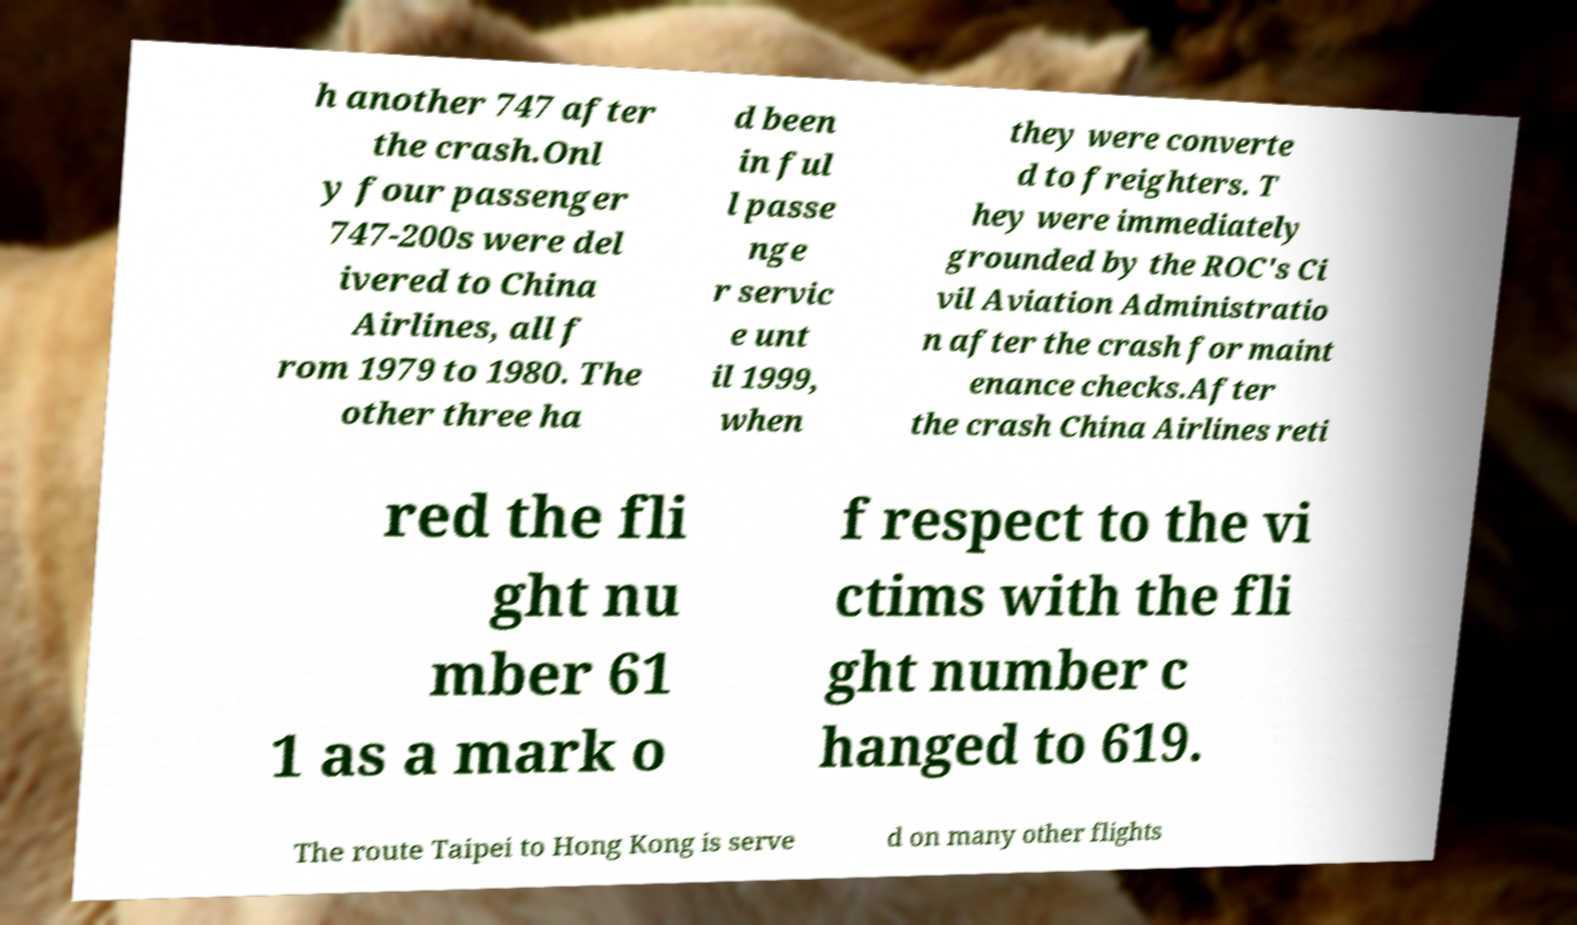There's text embedded in this image that I need extracted. Can you transcribe it verbatim? h another 747 after the crash.Onl y four passenger 747-200s were del ivered to China Airlines, all f rom 1979 to 1980. The other three ha d been in ful l passe nge r servic e unt il 1999, when they were converte d to freighters. T hey were immediately grounded by the ROC's Ci vil Aviation Administratio n after the crash for maint enance checks.After the crash China Airlines reti red the fli ght nu mber 61 1 as a mark o f respect to the vi ctims with the fli ght number c hanged to 619. The route Taipei to Hong Kong is serve d on many other flights 